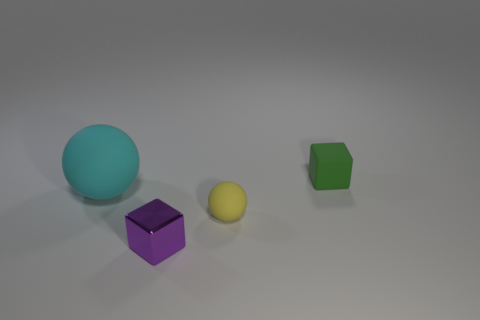Add 4 large green rubber blocks. How many objects exist? 8 Subtract all purple cubes. How many cubes are left? 1 Subtract 1 blocks. How many blocks are left? 1 Add 3 red shiny blocks. How many red shiny blocks exist? 3 Subtract 0 yellow cubes. How many objects are left? 4 Subtract all purple spheres. Subtract all gray cubes. How many spheres are left? 2 Subtract all small purple things. Subtract all tiny spheres. How many objects are left? 2 Add 4 tiny blocks. How many tiny blocks are left? 6 